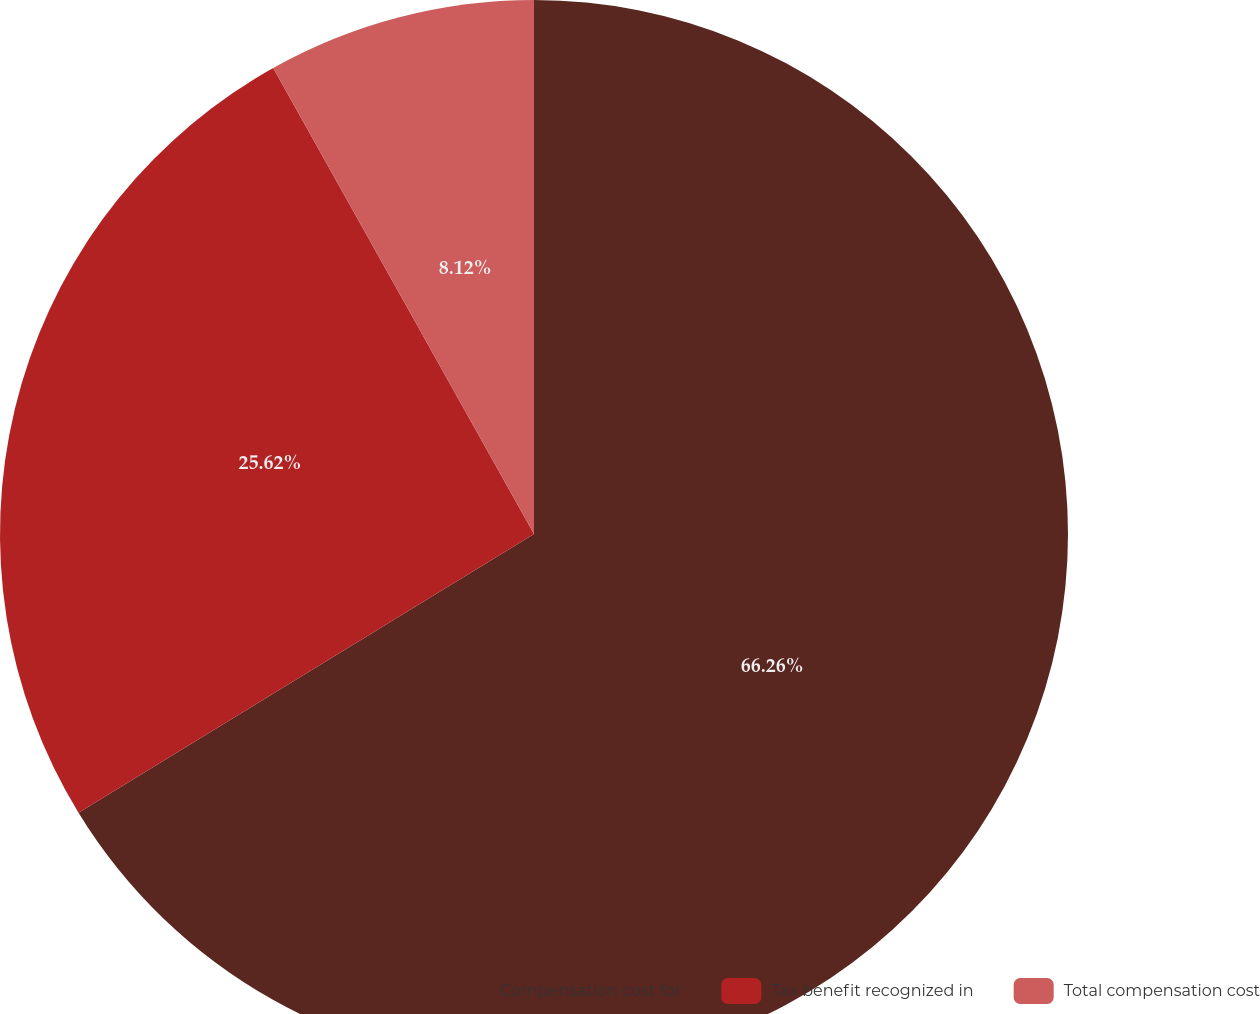<chart> <loc_0><loc_0><loc_500><loc_500><pie_chart><fcel>Compensation cost for<fcel>Tax benefit recognized in<fcel>Total compensation cost<nl><fcel>66.26%<fcel>25.62%<fcel>8.12%<nl></chart> 